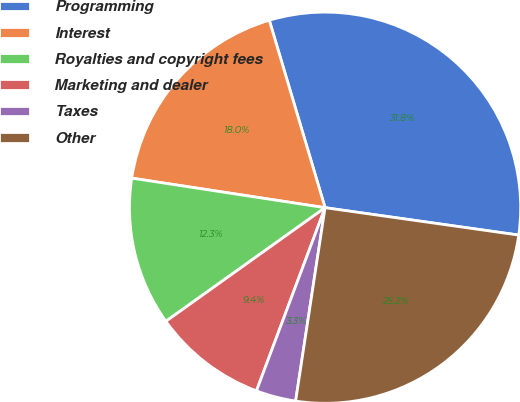<chart> <loc_0><loc_0><loc_500><loc_500><pie_chart><fcel>Programming<fcel>Interest<fcel>Royalties and copyright fees<fcel>Marketing and dealer<fcel>Taxes<fcel>Other<nl><fcel>31.84%<fcel>17.98%<fcel>12.28%<fcel>9.43%<fcel>3.3%<fcel>25.17%<nl></chart> 